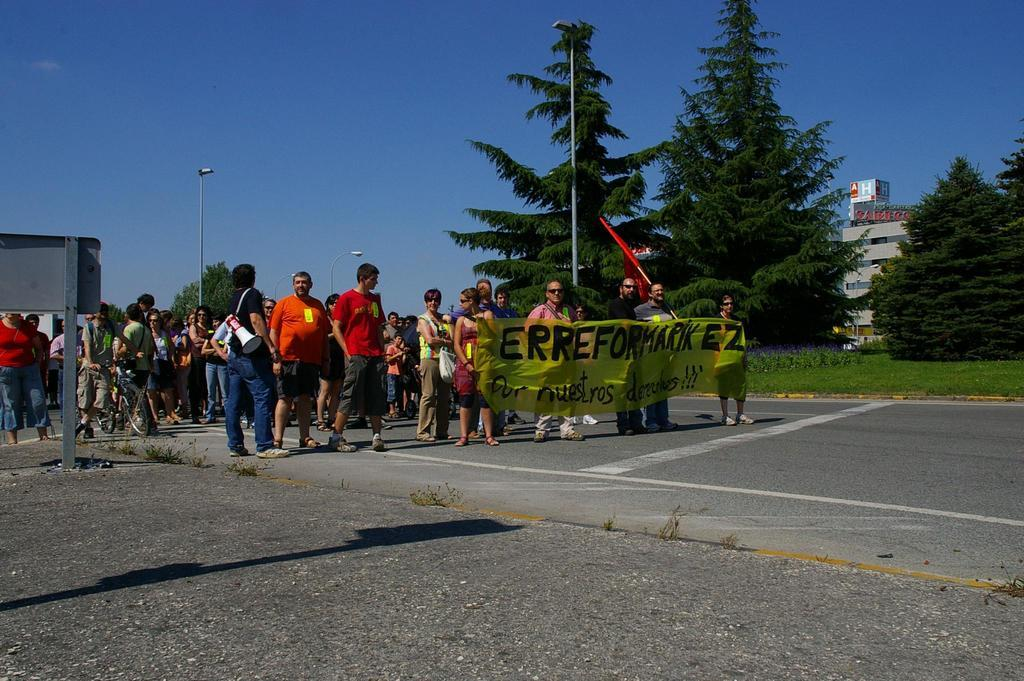Provide a one-sentence caption for the provided image. People are marching behind a banner that says, 'Erreformarik EZ'. 